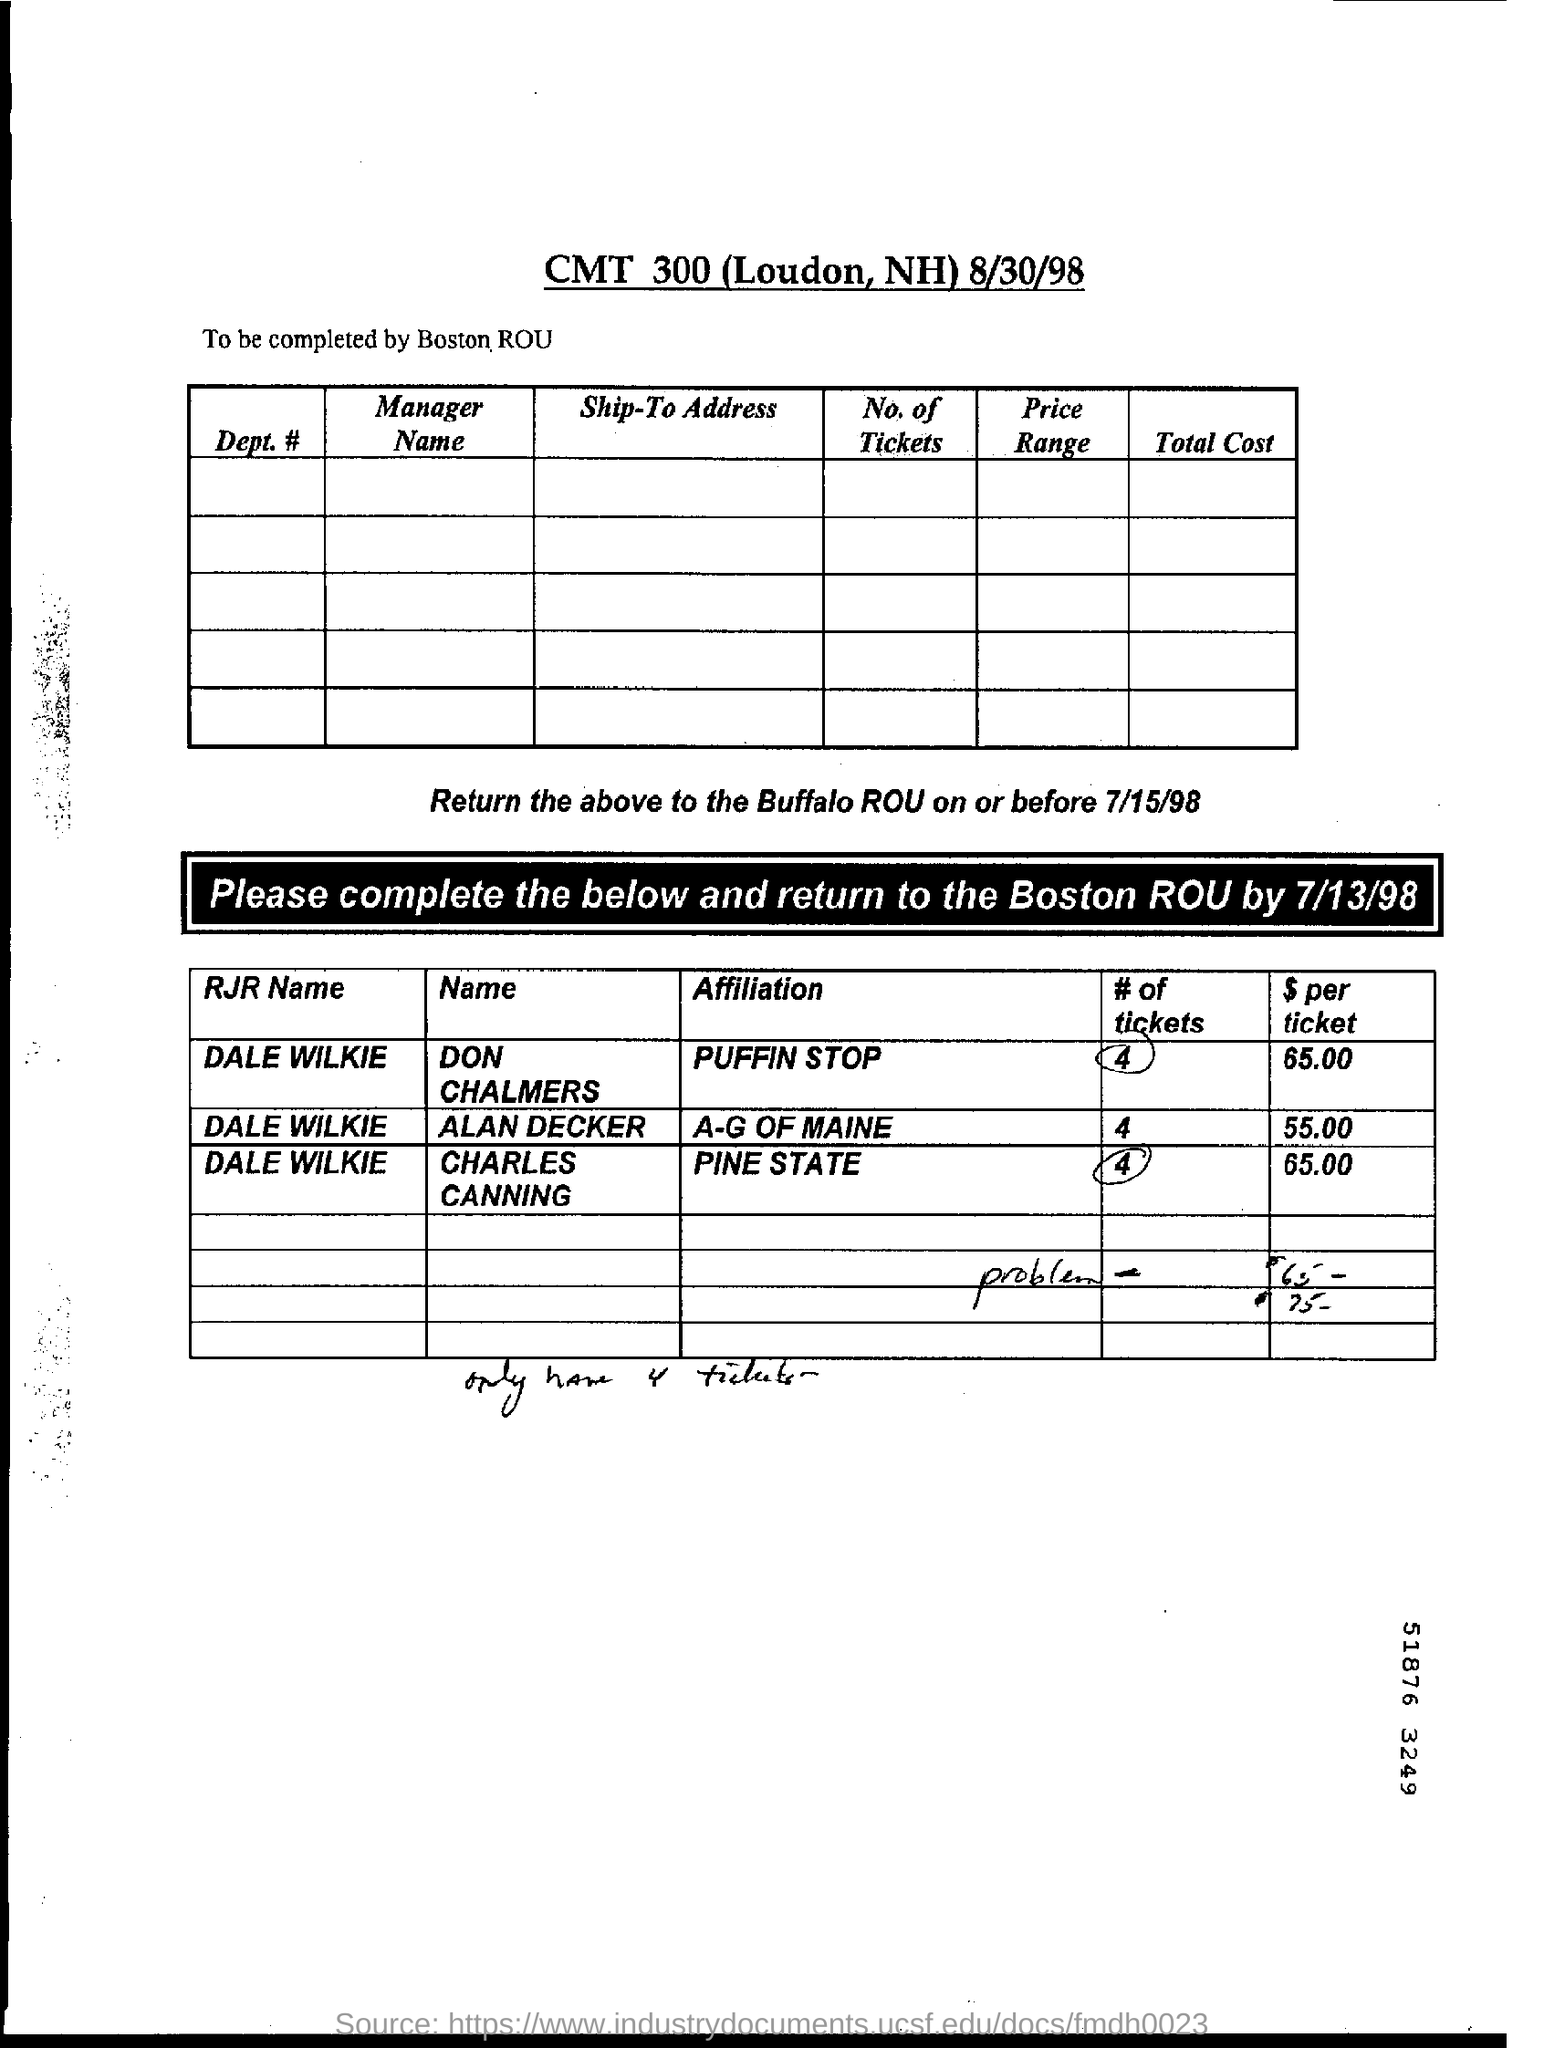Give some essential details in this illustration. The cost of a ticket for A-G Maine is approximately $55.00. Boston Roundtable should complete the form. The document title is CMT 300 (Loudon, NH) 8/30/98. Don Chalmers' affiliation is PUFFIN. 